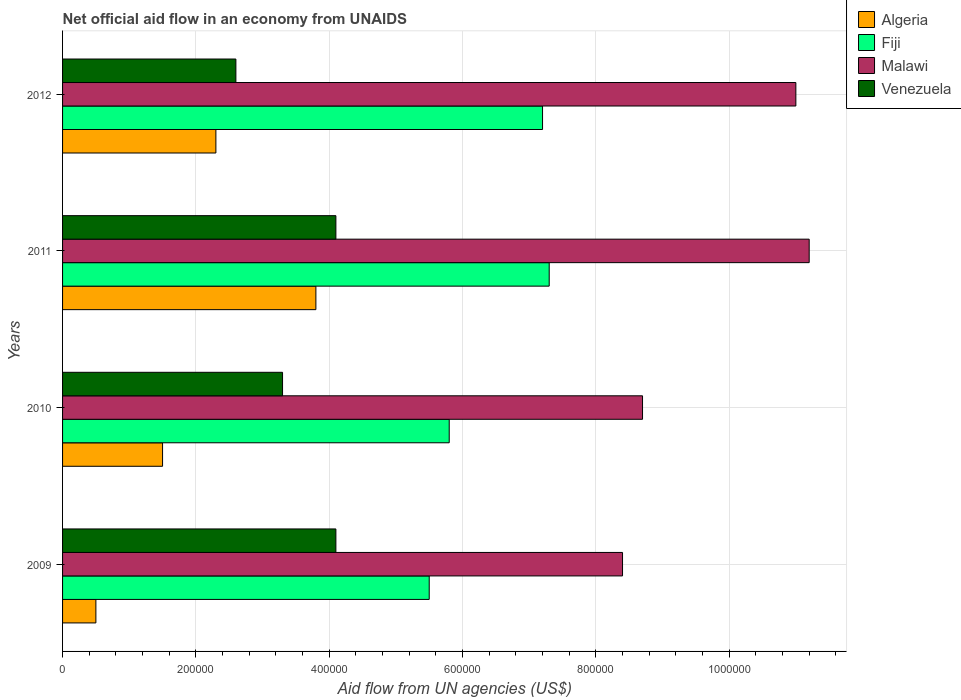How many groups of bars are there?
Provide a succinct answer. 4. Are the number of bars per tick equal to the number of legend labels?
Ensure brevity in your answer.  Yes. How many bars are there on the 4th tick from the bottom?
Your answer should be compact. 4. In how many cases, is the number of bars for a given year not equal to the number of legend labels?
Provide a succinct answer. 0. What is the net official aid flow in Algeria in 2009?
Your response must be concise. 5.00e+04. Across all years, what is the maximum net official aid flow in Fiji?
Provide a short and direct response. 7.30e+05. Across all years, what is the minimum net official aid flow in Malawi?
Keep it short and to the point. 8.40e+05. In which year was the net official aid flow in Fiji maximum?
Make the answer very short. 2011. What is the total net official aid flow in Algeria in the graph?
Ensure brevity in your answer.  8.10e+05. What is the difference between the net official aid flow in Fiji in 2010 and that in 2011?
Provide a succinct answer. -1.50e+05. What is the difference between the net official aid flow in Fiji in 2010 and the net official aid flow in Algeria in 2011?
Your answer should be compact. 2.00e+05. What is the average net official aid flow in Venezuela per year?
Make the answer very short. 3.52e+05. In the year 2010, what is the difference between the net official aid flow in Malawi and net official aid flow in Algeria?
Provide a succinct answer. 7.20e+05. What is the ratio of the net official aid flow in Malawi in 2009 to that in 2012?
Keep it short and to the point. 0.76. What is the difference between the highest and the second highest net official aid flow in Algeria?
Offer a very short reply. 1.50e+05. What is the difference between the highest and the lowest net official aid flow in Malawi?
Your answer should be very brief. 2.80e+05. In how many years, is the net official aid flow in Malawi greater than the average net official aid flow in Malawi taken over all years?
Offer a terse response. 2. Is it the case that in every year, the sum of the net official aid flow in Venezuela and net official aid flow in Algeria is greater than the sum of net official aid flow in Fiji and net official aid flow in Malawi?
Keep it short and to the point. Yes. What does the 4th bar from the top in 2011 represents?
Make the answer very short. Algeria. What does the 4th bar from the bottom in 2010 represents?
Your answer should be compact. Venezuela. How many years are there in the graph?
Offer a very short reply. 4. Are the values on the major ticks of X-axis written in scientific E-notation?
Provide a short and direct response. No. Does the graph contain any zero values?
Your response must be concise. No. Does the graph contain grids?
Your response must be concise. Yes. Where does the legend appear in the graph?
Make the answer very short. Top right. What is the title of the graph?
Your answer should be very brief. Net official aid flow in an economy from UNAIDS. What is the label or title of the X-axis?
Offer a very short reply. Aid flow from UN agencies (US$). What is the label or title of the Y-axis?
Provide a succinct answer. Years. What is the Aid flow from UN agencies (US$) of Algeria in 2009?
Keep it short and to the point. 5.00e+04. What is the Aid flow from UN agencies (US$) in Fiji in 2009?
Offer a very short reply. 5.50e+05. What is the Aid flow from UN agencies (US$) in Malawi in 2009?
Your answer should be compact. 8.40e+05. What is the Aid flow from UN agencies (US$) of Venezuela in 2009?
Your response must be concise. 4.10e+05. What is the Aid flow from UN agencies (US$) in Fiji in 2010?
Your response must be concise. 5.80e+05. What is the Aid flow from UN agencies (US$) in Malawi in 2010?
Provide a succinct answer. 8.70e+05. What is the Aid flow from UN agencies (US$) of Venezuela in 2010?
Your answer should be compact. 3.30e+05. What is the Aid flow from UN agencies (US$) in Algeria in 2011?
Give a very brief answer. 3.80e+05. What is the Aid flow from UN agencies (US$) in Fiji in 2011?
Your answer should be compact. 7.30e+05. What is the Aid flow from UN agencies (US$) in Malawi in 2011?
Your answer should be compact. 1.12e+06. What is the Aid flow from UN agencies (US$) in Fiji in 2012?
Ensure brevity in your answer.  7.20e+05. What is the Aid flow from UN agencies (US$) of Malawi in 2012?
Your response must be concise. 1.10e+06. What is the Aid flow from UN agencies (US$) in Venezuela in 2012?
Your response must be concise. 2.60e+05. Across all years, what is the maximum Aid flow from UN agencies (US$) of Fiji?
Your answer should be compact. 7.30e+05. Across all years, what is the maximum Aid flow from UN agencies (US$) of Malawi?
Offer a very short reply. 1.12e+06. Across all years, what is the maximum Aid flow from UN agencies (US$) of Venezuela?
Keep it short and to the point. 4.10e+05. Across all years, what is the minimum Aid flow from UN agencies (US$) of Malawi?
Provide a succinct answer. 8.40e+05. What is the total Aid flow from UN agencies (US$) of Algeria in the graph?
Your answer should be compact. 8.10e+05. What is the total Aid flow from UN agencies (US$) of Fiji in the graph?
Keep it short and to the point. 2.58e+06. What is the total Aid flow from UN agencies (US$) in Malawi in the graph?
Offer a very short reply. 3.93e+06. What is the total Aid flow from UN agencies (US$) in Venezuela in the graph?
Offer a terse response. 1.41e+06. What is the difference between the Aid flow from UN agencies (US$) in Algeria in 2009 and that in 2010?
Offer a very short reply. -1.00e+05. What is the difference between the Aid flow from UN agencies (US$) in Fiji in 2009 and that in 2010?
Keep it short and to the point. -3.00e+04. What is the difference between the Aid flow from UN agencies (US$) of Malawi in 2009 and that in 2010?
Provide a succinct answer. -3.00e+04. What is the difference between the Aid flow from UN agencies (US$) of Venezuela in 2009 and that in 2010?
Make the answer very short. 8.00e+04. What is the difference between the Aid flow from UN agencies (US$) of Algeria in 2009 and that in 2011?
Provide a succinct answer. -3.30e+05. What is the difference between the Aid flow from UN agencies (US$) of Malawi in 2009 and that in 2011?
Your answer should be compact. -2.80e+05. What is the difference between the Aid flow from UN agencies (US$) of Algeria in 2009 and that in 2012?
Your answer should be compact. -1.80e+05. What is the difference between the Aid flow from UN agencies (US$) of Malawi in 2009 and that in 2012?
Provide a short and direct response. -2.60e+05. What is the difference between the Aid flow from UN agencies (US$) in Venezuela in 2009 and that in 2012?
Your response must be concise. 1.50e+05. What is the difference between the Aid flow from UN agencies (US$) in Venezuela in 2010 and that in 2011?
Give a very brief answer. -8.00e+04. What is the difference between the Aid flow from UN agencies (US$) of Fiji in 2010 and that in 2012?
Your answer should be very brief. -1.40e+05. What is the difference between the Aid flow from UN agencies (US$) in Malawi in 2010 and that in 2012?
Your answer should be compact. -2.30e+05. What is the difference between the Aid flow from UN agencies (US$) of Venezuela in 2010 and that in 2012?
Offer a very short reply. 7.00e+04. What is the difference between the Aid flow from UN agencies (US$) in Malawi in 2011 and that in 2012?
Your answer should be very brief. 2.00e+04. What is the difference between the Aid flow from UN agencies (US$) of Algeria in 2009 and the Aid flow from UN agencies (US$) of Fiji in 2010?
Provide a short and direct response. -5.30e+05. What is the difference between the Aid flow from UN agencies (US$) in Algeria in 2009 and the Aid flow from UN agencies (US$) in Malawi in 2010?
Provide a succinct answer. -8.20e+05. What is the difference between the Aid flow from UN agencies (US$) of Algeria in 2009 and the Aid flow from UN agencies (US$) of Venezuela in 2010?
Provide a short and direct response. -2.80e+05. What is the difference between the Aid flow from UN agencies (US$) of Fiji in 2009 and the Aid flow from UN agencies (US$) of Malawi in 2010?
Offer a very short reply. -3.20e+05. What is the difference between the Aid flow from UN agencies (US$) of Malawi in 2009 and the Aid flow from UN agencies (US$) of Venezuela in 2010?
Give a very brief answer. 5.10e+05. What is the difference between the Aid flow from UN agencies (US$) in Algeria in 2009 and the Aid flow from UN agencies (US$) in Fiji in 2011?
Give a very brief answer. -6.80e+05. What is the difference between the Aid flow from UN agencies (US$) in Algeria in 2009 and the Aid flow from UN agencies (US$) in Malawi in 2011?
Your answer should be compact. -1.07e+06. What is the difference between the Aid flow from UN agencies (US$) of Algeria in 2009 and the Aid flow from UN agencies (US$) of Venezuela in 2011?
Provide a short and direct response. -3.60e+05. What is the difference between the Aid flow from UN agencies (US$) of Fiji in 2009 and the Aid flow from UN agencies (US$) of Malawi in 2011?
Your response must be concise. -5.70e+05. What is the difference between the Aid flow from UN agencies (US$) of Algeria in 2009 and the Aid flow from UN agencies (US$) of Fiji in 2012?
Your answer should be very brief. -6.70e+05. What is the difference between the Aid flow from UN agencies (US$) in Algeria in 2009 and the Aid flow from UN agencies (US$) in Malawi in 2012?
Your answer should be compact. -1.05e+06. What is the difference between the Aid flow from UN agencies (US$) of Fiji in 2009 and the Aid flow from UN agencies (US$) of Malawi in 2012?
Keep it short and to the point. -5.50e+05. What is the difference between the Aid flow from UN agencies (US$) in Malawi in 2009 and the Aid flow from UN agencies (US$) in Venezuela in 2012?
Give a very brief answer. 5.80e+05. What is the difference between the Aid flow from UN agencies (US$) of Algeria in 2010 and the Aid flow from UN agencies (US$) of Fiji in 2011?
Provide a short and direct response. -5.80e+05. What is the difference between the Aid flow from UN agencies (US$) in Algeria in 2010 and the Aid flow from UN agencies (US$) in Malawi in 2011?
Provide a succinct answer. -9.70e+05. What is the difference between the Aid flow from UN agencies (US$) in Algeria in 2010 and the Aid flow from UN agencies (US$) in Venezuela in 2011?
Offer a terse response. -2.60e+05. What is the difference between the Aid flow from UN agencies (US$) in Fiji in 2010 and the Aid flow from UN agencies (US$) in Malawi in 2011?
Ensure brevity in your answer.  -5.40e+05. What is the difference between the Aid flow from UN agencies (US$) in Malawi in 2010 and the Aid flow from UN agencies (US$) in Venezuela in 2011?
Your answer should be compact. 4.60e+05. What is the difference between the Aid flow from UN agencies (US$) in Algeria in 2010 and the Aid flow from UN agencies (US$) in Fiji in 2012?
Offer a very short reply. -5.70e+05. What is the difference between the Aid flow from UN agencies (US$) of Algeria in 2010 and the Aid flow from UN agencies (US$) of Malawi in 2012?
Your answer should be compact. -9.50e+05. What is the difference between the Aid flow from UN agencies (US$) of Algeria in 2010 and the Aid flow from UN agencies (US$) of Venezuela in 2012?
Offer a very short reply. -1.10e+05. What is the difference between the Aid flow from UN agencies (US$) in Fiji in 2010 and the Aid flow from UN agencies (US$) in Malawi in 2012?
Offer a very short reply. -5.20e+05. What is the difference between the Aid flow from UN agencies (US$) in Fiji in 2010 and the Aid flow from UN agencies (US$) in Venezuela in 2012?
Your answer should be very brief. 3.20e+05. What is the difference between the Aid flow from UN agencies (US$) in Algeria in 2011 and the Aid flow from UN agencies (US$) in Malawi in 2012?
Give a very brief answer. -7.20e+05. What is the difference between the Aid flow from UN agencies (US$) of Algeria in 2011 and the Aid flow from UN agencies (US$) of Venezuela in 2012?
Offer a terse response. 1.20e+05. What is the difference between the Aid flow from UN agencies (US$) of Fiji in 2011 and the Aid flow from UN agencies (US$) of Malawi in 2012?
Offer a terse response. -3.70e+05. What is the difference between the Aid flow from UN agencies (US$) in Malawi in 2011 and the Aid flow from UN agencies (US$) in Venezuela in 2012?
Make the answer very short. 8.60e+05. What is the average Aid flow from UN agencies (US$) in Algeria per year?
Keep it short and to the point. 2.02e+05. What is the average Aid flow from UN agencies (US$) of Fiji per year?
Keep it short and to the point. 6.45e+05. What is the average Aid flow from UN agencies (US$) in Malawi per year?
Ensure brevity in your answer.  9.82e+05. What is the average Aid flow from UN agencies (US$) of Venezuela per year?
Your answer should be very brief. 3.52e+05. In the year 2009, what is the difference between the Aid flow from UN agencies (US$) in Algeria and Aid flow from UN agencies (US$) in Fiji?
Your response must be concise. -5.00e+05. In the year 2009, what is the difference between the Aid flow from UN agencies (US$) in Algeria and Aid flow from UN agencies (US$) in Malawi?
Your answer should be very brief. -7.90e+05. In the year 2009, what is the difference between the Aid flow from UN agencies (US$) in Algeria and Aid flow from UN agencies (US$) in Venezuela?
Offer a terse response. -3.60e+05. In the year 2009, what is the difference between the Aid flow from UN agencies (US$) of Fiji and Aid flow from UN agencies (US$) of Venezuela?
Ensure brevity in your answer.  1.40e+05. In the year 2010, what is the difference between the Aid flow from UN agencies (US$) of Algeria and Aid flow from UN agencies (US$) of Fiji?
Offer a very short reply. -4.30e+05. In the year 2010, what is the difference between the Aid flow from UN agencies (US$) of Algeria and Aid flow from UN agencies (US$) of Malawi?
Ensure brevity in your answer.  -7.20e+05. In the year 2010, what is the difference between the Aid flow from UN agencies (US$) in Fiji and Aid flow from UN agencies (US$) in Malawi?
Keep it short and to the point. -2.90e+05. In the year 2010, what is the difference between the Aid flow from UN agencies (US$) of Fiji and Aid flow from UN agencies (US$) of Venezuela?
Give a very brief answer. 2.50e+05. In the year 2010, what is the difference between the Aid flow from UN agencies (US$) of Malawi and Aid flow from UN agencies (US$) of Venezuela?
Give a very brief answer. 5.40e+05. In the year 2011, what is the difference between the Aid flow from UN agencies (US$) of Algeria and Aid flow from UN agencies (US$) of Fiji?
Your answer should be very brief. -3.50e+05. In the year 2011, what is the difference between the Aid flow from UN agencies (US$) of Algeria and Aid flow from UN agencies (US$) of Malawi?
Make the answer very short. -7.40e+05. In the year 2011, what is the difference between the Aid flow from UN agencies (US$) in Fiji and Aid flow from UN agencies (US$) in Malawi?
Provide a short and direct response. -3.90e+05. In the year 2011, what is the difference between the Aid flow from UN agencies (US$) of Fiji and Aid flow from UN agencies (US$) of Venezuela?
Give a very brief answer. 3.20e+05. In the year 2011, what is the difference between the Aid flow from UN agencies (US$) of Malawi and Aid flow from UN agencies (US$) of Venezuela?
Keep it short and to the point. 7.10e+05. In the year 2012, what is the difference between the Aid flow from UN agencies (US$) of Algeria and Aid flow from UN agencies (US$) of Fiji?
Your response must be concise. -4.90e+05. In the year 2012, what is the difference between the Aid flow from UN agencies (US$) of Algeria and Aid flow from UN agencies (US$) of Malawi?
Keep it short and to the point. -8.70e+05. In the year 2012, what is the difference between the Aid flow from UN agencies (US$) of Fiji and Aid flow from UN agencies (US$) of Malawi?
Offer a very short reply. -3.80e+05. In the year 2012, what is the difference between the Aid flow from UN agencies (US$) in Fiji and Aid flow from UN agencies (US$) in Venezuela?
Your answer should be compact. 4.60e+05. In the year 2012, what is the difference between the Aid flow from UN agencies (US$) of Malawi and Aid flow from UN agencies (US$) of Venezuela?
Your response must be concise. 8.40e+05. What is the ratio of the Aid flow from UN agencies (US$) in Algeria in 2009 to that in 2010?
Your answer should be very brief. 0.33. What is the ratio of the Aid flow from UN agencies (US$) of Fiji in 2009 to that in 2010?
Offer a very short reply. 0.95. What is the ratio of the Aid flow from UN agencies (US$) in Malawi in 2009 to that in 2010?
Make the answer very short. 0.97. What is the ratio of the Aid flow from UN agencies (US$) of Venezuela in 2009 to that in 2010?
Keep it short and to the point. 1.24. What is the ratio of the Aid flow from UN agencies (US$) of Algeria in 2009 to that in 2011?
Your answer should be compact. 0.13. What is the ratio of the Aid flow from UN agencies (US$) in Fiji in 2009 to that in 2011?
Give a very brief answer. 0.75. What is the ratio of the Aid flow from UN agencies (US$) of Venezuela in 2009 to that in 2011?
Keep it short and to the point. 1. What is the ratio of the Aid flow from UN agencies (US$) in Algeria in 2009 to that in 2012?
Give a very brief answer. 0.22. What is the ratio of the Aid flow from UN agencies (US$) in Fiji in 2009 to that in 2012?
Your answer should be very brief. 0.76. What is the ratio of the Aid flow from UN agencies (US$) in Malawi in 2009 to that in 2012?
Provide a short and direct response. 0.76. What is the ratio of the Aid flow from UN agencies (US$) in Venezuela in 2009 to that in 2012?
Your answer should be very brief. 1.58. What is the ratio of the Aid flow from UN agencies (US$) in Algeria in 2010 to that in 2011?
Keep it short and to the point. 0.39. What is the ratio of the Aid flow from UN agencies (US$) of Fiji in 2010 to that in 2011?
Make the answer very short. 0.79. What is the ratio of the Aid flow from UN agencies (US$) of Malawi in 2010 to that in 2011?
Keep it short and to the point. 0.78. What is the ratio of the Aid flow from UN agencies (US$) of Venezuela in 2010 to that in 2011?
Offer a very short reply. 0.8. What is the ratio of the Aid flow from UN agencies (US$) in Algeria in 2010 to that in 2012?
Give a very brief answer. 0.65. What is the ratio of the Aid flow from UN agencies (US$) of Fiji in 2010 to that in 2012?
Give a very brief answer. 0.81. What is the ratio of the Aid flow from UN agencies (US$) in Malawi in 2010 to that in 2012?
Give a very brief answer. 0.79. What is the ratio of the Aid flow from UN agencies (US$) in Venezuela in 2010 to that in 2012?
Your answer should be compact. 1.27. What is the ratio of the Aid flow from UN agencies (US$) in Algeria in 2011 to that in 2012?
Your answer should be compact. 1.65. What is the ratio of the Aid flow from UN agencies (US$) of Fiji in 2011 to that in 2012?
Provide a succinct answer. 1.01. What is the ratio of the Aid flow from UN agencies (US$) of Malawi in 2011 to that in 2012?
Provide a succinct answer. 1.02. What is the ratio of the Aid flow from UN agencies (US$) in Venezuela in 2011 to that in 2012?
Your answer should be very brief. 1.58. What is the difference between the highest and the second highest Aid flow from UN agencies (US$) in Fiji?
Provide a short and direct response. 10000. What is the difference between the highest and the second highest Aid flow from UN agencies (US$) of Venezuela?
Your answer should be compact. 0. What is the difference between the highest and the lowest Aid flow from UN agencies (US$) in Algeria?
Offer a very short reply. 3.30e+05. What is the difference between the highest and the lowest Aid flow from UN agencies (US$) of Venezuela?
Provide a succinct answer. 1.50e+05. 